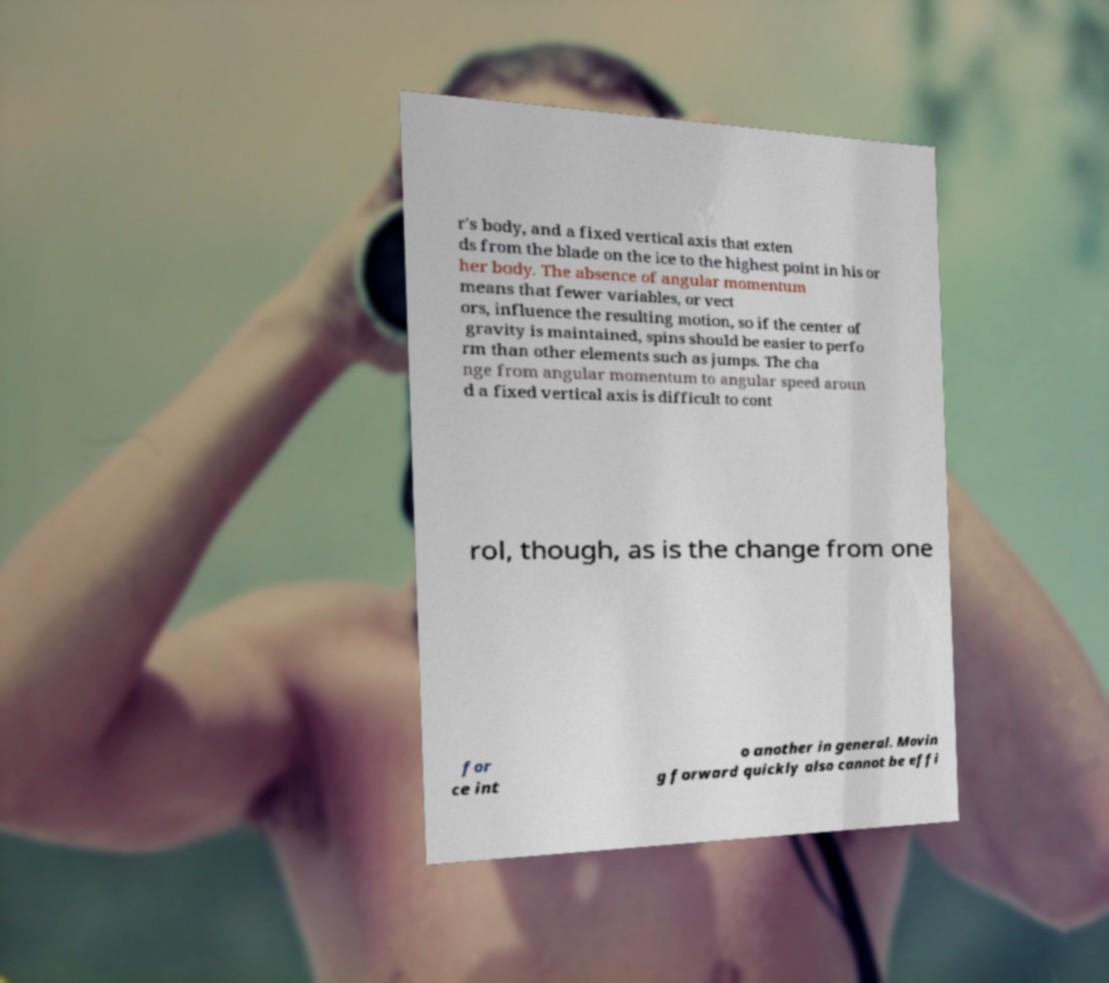There's text embedded in this image that I need extracted. Can you transcribe it verbatim? r's body, and a fixed vertical axis that exten ds from the blade on the ice to the highest point in his or her body. The absence of angular momentum means that fewer variables, or vect ors, influence the resulting motion, so if the center of gravity is maintained, spins should be easier to perfo rm than other elements such as jumps. The cha nge from angular momentum to angular speed aroun d a fixed vertical axis is difficult to cont rol, though, as is the change from one for ce int o another in general. Movin g forward quickly also cannot be effi 